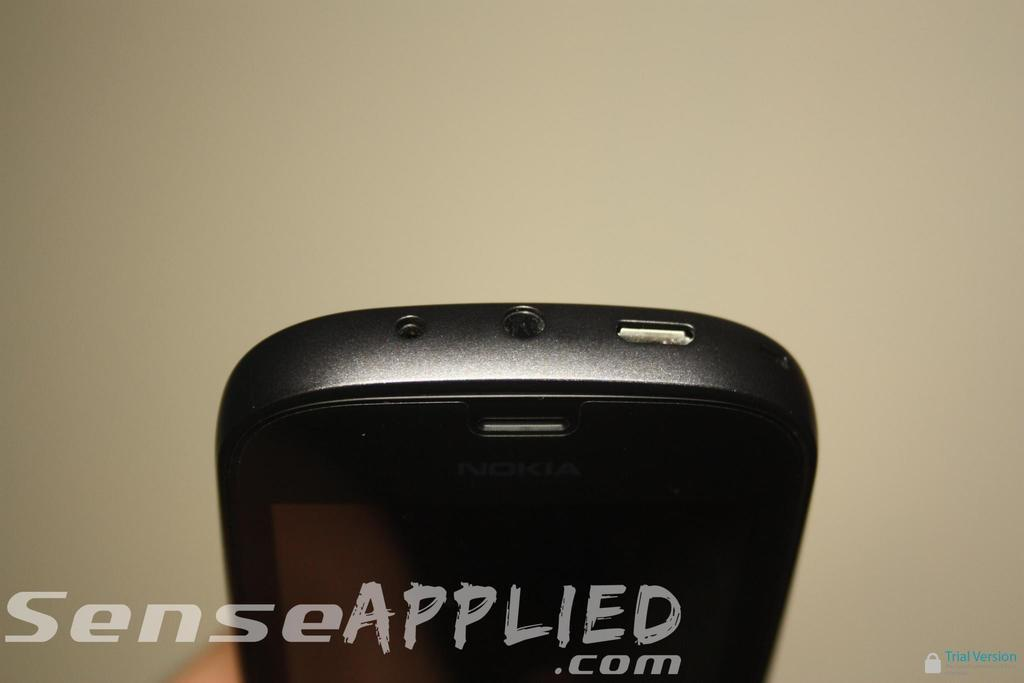<image>
Render a clear and concise summary of the photo. the bottom of a phone being shown with a watermark text across that reads senseapplied.com 